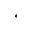<formula> <loc_0><loc_0><loc_500><loc_500>^ { * }</formula> 